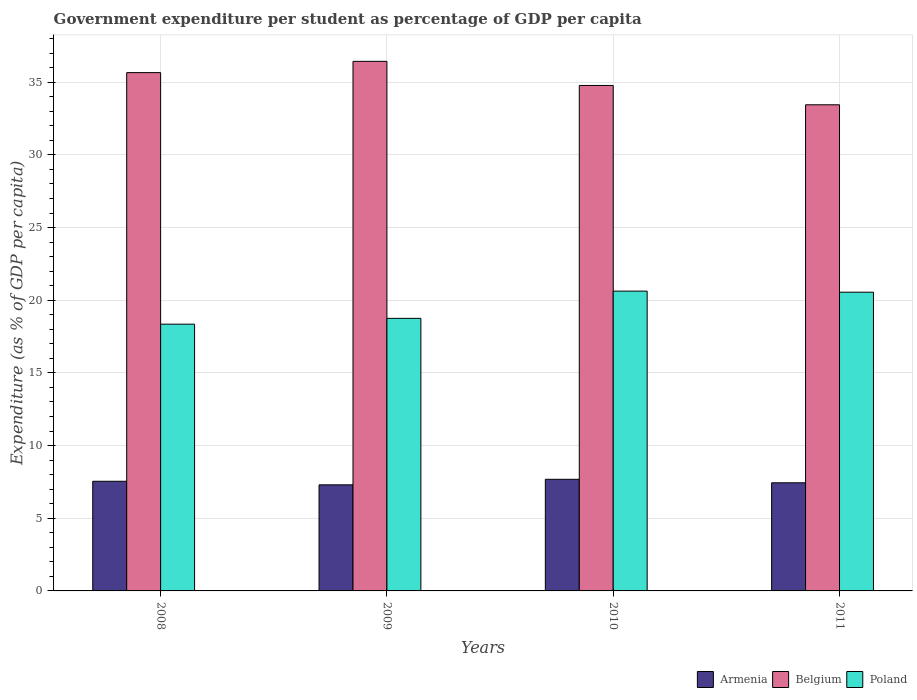Are the number of bars on each tick of the X-axis equal?
Offer a terse response. Yes. How many bars are there on the 3rd tick from the left?
Your response must be concise. 3. How many bars are there on the 1st tick from the right?
Give a very brief answer. 3. What is the label of the 1st group of bars from the left?
Your answer should be compact. 2008. In how many cases, is the number of bars for a given year not equal to the number of legend labels?
Offer a very short reply. 0. What is the percentage of expenditure per student in Armenia in 2010?
Provide a succinct answer. 7.68. Across all years, what is the maximum percentage of expenditure per student in Belgium?
Provide a succinct answer. 36.43. Across all years, what is the minimum percentage of expenditure per student in Poland?
Your response must be concise. 18.35. In which year was the percentage of expenditure per student in Belgium maximum?
Keep it short and to the point. 2009. In which year was the percentage of expenditure per student in Poland minimum?
Provide a short and direct response. 2008. What is the total percentage of expenditure per student in Belgium in the graph?
Give a very brief answer. 140.31. What is the difference between the percentage of expenditure per student in Armenia in 2009 and that in 2011?
Ensure brevity in your answer.  -0.14. What is the difference between the percentage of expenditure per student in Poland in 2008 and the percentage of expenditure per student in Armenia in 2010?
Offer a very short reply. 10.67. What is the average percentage of expenditure per student in Belgium per year?
Your answer should be very brief. 35.08. In the year 2010, what is the difference between the percentage of expenditure per student in Armenia and percentage of expenditure per student in Poland?
Your answer should be compact. -12.95. What is the ratio of the percentage of expenditure per student in Poland in 2009 to that in 2010?
Offer a terse response. 0.91. What is the difference between the highest and the second highest percentage of expenditure per student in Belgium?
Make the answer very short. 0.77. What is the difference between the highest and the lowest percentage of expenditure per student in Poland?
Offer a terse response. 2.27. In how many years, is the percentage of expenditure per student in Armenia greater than the average percentage of expenditure per student in Armenia taken over all years?
Offer a very short reply. 2. Is the sum of the percentage of expenditure per student in Belgium in 2008 and 2009 greater than the maximum percentage of expenditure per student in Armenia across all years?
Provide a succinct answer. Yes. What does the 3rd bar from the right in 2010 represents?
Offer a very short reply. Armenia. Is it the case that in every year, the sum of the percentage of expenditure per student in Belgium and percentage of expenditure per student in Poland is greater than the percentage of expenditure per student in Armenia?
Make the answer very short. Yes. How many bars are there?
Ensure brevity in your answer.  12. What is the difference between two consecutive major ticks on the Y-axis?
Provide a succinct answer. 5. Does the graph contain any zero values?
Your answer should be compact. No. What is the title of the graph?
Ensure brevity in your answer.  Government expenditure per student as percentage of GDP per capita. Does "Nepal" appear as one of the legend labels in the graph?
Provide a short and direct response. No. What is the label or title of the X-axis?
Ensure brevity in your answer.  Years. What is the label or title of the Y-axis?
Your response must be concise. Expenditure (as % of GDP per capita). What is the Expenditure (as % of GDP per capita) in Armenia in 2008?
Ensure brevity in your answer.  7.54. What is the Expenditure (as % of GDP per capita) of Belgium in 2008?
Make the answer very short. 35.66. What is the Expenditure (as % of GDP per capita) of Poland in 2008?
Ensure brevity in your answer.  18.35. What is the Expenditure (as % of GDP per capita) in Armenia in 2009?
Make the answer very short. 7.3. What is the Expenditure (as % of GDP per capita) in Belgium in 2009?
Make the answer very short. 36.43. What is the Expenditure (as % of GDP per capita) in Poland in 2009?
Keep it short and to the point. 18.75. What is the Expenditure (as % of GDP per capita) in Armenia in 2010?
Offer a terse response. 7.68. What is the Expenditure (as % of GDP per capita) of Belgium in 2010?
Offer a very short reply. 34.77. What is the Expenditure (as % of GDP per capita) of Poland in 2010?
Keep it short and to the point. 20.63. What is the Expenditure (as % of GDP per capita) in Armenia in 2011?
Provide a short and direct response. 7.44. What is the Expenditure (as % of GDP per capita) in Belgium in 2011?
Offer a terse response. 33.44. What is the Expenditure (as % of GDP per capita) of Poland in 2011?
Offer a terse response. 20.55. Across all years, what is the maximum Expenditure (as % of GDP per capita) in Armenia?
Your answer should be compact. 7.68. Across all years, what is the maximum Expenditure (as % of GDP per capita) of Belgium?
Your answer should be very brief. 36.43. Across all years, what is the maximum Expenditure (as % of GDP per capita) in Poland?
Your response must be concise. 20.63. Across all years, what is the minimum Expenditure (as % of GDP per capita) of Armenia?
Ensure brevity in your answer.  7.3. Across all years, what is the minimum Expenditure (as % of GDP per capita) of Belgium?
Provide a short and direct response. 33.44. Across all years, what is the minimum Expenditure (as % of GDP per capita) of Poland?
Offer a very short reply. 18.35. What is the total Expenditure (as % of GDP per capita) of Armenia in the graph?
Your answer should be very brief. 29.96. What is the total Expenditure (as % of GDP per capita) in Belgium in the graph?
Offer a terse response. 140.31. What is the total Expenditure (as % of GDP per capita) in Poland in the graph?
Offer a terse response. 78.28. What is the difference between the Expenditure (as % of GDP per capita) in Armenia in 2008 and that in 2009?
Keep it short and to the point. 0.25. What is the difference between the Expenditure (as % of GDP per capita) of Belgium in 2008 and that in 2009?
Make the answer very short. -0.77. What is the difference between the Expenditure (as % of GDP per capita) in Poland in 2008 and that in 2009?
Provide a short and direct response. -0.4. What is the difference between the Expenditure (as % of GDP per capita) in Armenia in 2008 and that in 2010?
Ensure brevity in your answer.  -0.14. What is the difference between the Expenditure (as % of GDP per capita) in Belgium in 2008 and that in 2010?
Ensure brevity in your answer.  0.88. What is the difference between the Expenditure (as % of GDP per capita) of Poland in 2008 and that in 2010?
Your response must be concise. -2.27. What is the difference between the Expenditure (as % of GDP per capita) in Armenia in 2008 and that in 2011?
Your answer should be very brief. 0.11. What is the difference between the Expenditure (as % of GDP per capita) of Belgium in 2008 and that in 2011?
Offer a very short reply. 2.21. What is the difference between the Expenditure (as % of GDP per capita) in Poland in 2008 and that in 2011?
Make the answer very short. -2.2. What is the difference between the Expenditure (as % of GDP per capita) of Armenia in 2009 and that in 2010?
Provide a short and direct response. -0.38. What is the difference between the Expenditure (as % of GDP per capita) in Belgium in 2009 and that in 2010?
Your answer should be compact. 1.66. What is the difference between the Expenditure (as % of GDP per capita) in Poland in 2009 and that in 2010?
Give a very brief answer. -1.87. What is the difference between the Expenditure (as % of GDP per capita) in Armenia in 2009 and that in 2011?
Offer a terse response. -0.14. What is the difference between the Expenditure (as % of GDP per capita) of Belgium in 2009 and that in 2011?
Make the answer very short. 2.99. What is the difference between the Expenditure (as % of GDP per capita) in Poland in 2009 and that in 2011?
Ensure brevity in your answer.  -1.8. What is the difference between the Expenditure (as % of GDP per capita) in Armenia in 2010 and that in 2011?
Give a very brief answer. 0.24. What is the difference between the Expenditure (as % of GDP per capita) in Belgium in 2010 and that in 2011?
Your answer should be very brief. 1.33. What is the difference between the Expenditure (as % of GDP per capita) of Poland in 2010 and that in 2011?
Provide a short and direct response. 0.08. What is the difference between the Expenditure (as % of GDP per capita) in Armenia in 2008 and the Expenditure (as % of GDP per capita) in Belgium in 2009?
Give a very brief answer. -28.89. What is the difference between the Expenditure (as % of GDP per capita) of Armenia in 2008 and the Expenditure (as % of GDP per capita) of Poland in 2009?
Offer a terse response. -11.21. What is the difference between the Expenditure (as % of GDP per capita) of Belgium in 2008 and the Expenditure (as % of GDP per capita) of Poland in 2009?
Offer a very short reply. 16.91. What is the difference between the Expenditure (as % of GDP per capita) in Armenia in 2008 and the Expenditure (as % of GDP per capita) in Belgium in 2010?
Ensure brevity in your answer.  -27.23. What is the difference between the Expenditure (as % of GDP per capita) of Armenia in 2008 and the Expenditure (as % of GDP per capita) of Poland in 2010?
Give a very brief answer. -13.08. What is the difference between the Expenditure (as % of GDP per capita) in Belgium in 2008 and the Expenditure (as % of GDP per capita) in Poland in 2010?
Your answer should be compact. 15.03. What is the difference between the Expenditure (as % of GDP per capita) in Armenia in 2008 and the Expenditure (as % of GDP per capita) in Belgium in 2011?
Provide a short and direct response. -25.9. What is the difference between the Expenditure (as % of GDP per capita) in Armenia in 2008 and the Expenditure (as % of GDP per capita) in Poland in 2011?
Make the answer very short. -13.01. What is the difference between the Expenditure (as % of GDP per capita) in Belgium in 2008 and the Expenditure (as % of GDP per capita) in Poland in 2011?
Your response must be concise. 15.11. What is the difference between the Expenditure (as % of GDP per capita) in Armenia in 2009 and the Expenditure (as % of GDP per capita) in Belgium in 2010?
Your response must be concise. -27.48. What is the difference between the Expenditure (as % of GDP per capita) in Armenia in 2009 and the Expenditure (as % of GDP per capita) in Poland in 2010?
Give a very brief answer. -13.33. What is the difference between the Expenditure (as % of GDP per capita) in Belgium in 2009 and the Expenditure (as % of GDP per capita) in Poland in 2010?
Ensure brevity in your answer.  15.81. What is the difference between the Expenditure (as % of GDP per capita) of Armenia in 2009 and the Expenditure (as % of GDP per capita) of Belgium in 2011?
Offer a very short reply. -26.15. What is the difference between the Expenditure (as % of GDP per capita) in Armenia in 2009 and the Expenditure (as % of GDP per capita) in Poland in 2011?
Offer a terse response. -13.25. What is the difference between the Expenditure (as % of GDP per capita) of Belgium in 2009 and the Expenditure (as % of GDP per capita) of Poland in 2011?
Make the answer very short. 15.88. What is the difference between the Expenditure (as % of GDP per capita) in Armenia in 2010 and the Expenditure (as % of GDP per capita) in Belgium in 2011?
Ensure brevity in your answer.  -25.77. What is the difference between the Expenditure (as % of GDP per capita) in Armenia in 2010 and the Expenditure (as % of GDP per capita) in Poland in 2011?
Provide a short and direct response. -12.87. What is the difference between the Expenditure (as % of GDP per capita) in Belgium in 2010 and the Expenditure (as % of GDP per capita) in Poland in 2011?
Your answer should be compact. 14.22. What is the average Expenditure (as % of GDP per capita) of Armenia per year?
Your answer should be very brief. 7.49. What is the average Expenditure (as % of GDP per capita) of Belgium per year?
Provide a short and direct response. 35.08. What is the average Expenditure (as % of GDP per capita) of Poland per year?
Give a very brief answer. 19.57. In the year 2008, what is the difference between the Expenditure (as % of GDP per capita) of Armenia and Expenditure (as % of GDP per capita) of Belgium?
Your response must be concise. -28.11. In the year 2008, what is the difference between the Expenditure (as % of GDP per capita) in Armenia and Expenditure (as % of GDP per capita) in Poland?
Provide a short and direct response. -10.81. In the year 2008, what is the difference between the Expenditure (as % of GDP per capita) of Belgium and Expenditure (as % of GDP per capita) of Poland?
Offer a very short reply. 17.31. In the year 2009, what is the difference between the Expenditure (as % of GDP per capita) of Armenia and Expenditure (as % of GDP per capita) of Belgium?
Your answer should be very brief. -29.13. In the year 2009, what is the difference between the Expenditure (as % of GDP per capita) of Armenia and Expenditure (as % of GDP per capita) of Poland?
Offer a terse response. -11.45. In the year 2009, what is the difference between the Expenditure (as % of GDP per capita) in Belgium and Expenditure (as % of GDP per capita) in Poland?
Offer a very short reply. 17.68. In the year 2010, what is the difference between the Expenditure (as % of GDP per capita) in Armenia and Expenditure (as % of GDP per capita) in Belgium?
Your answer should be compact. -27.1. In the year 2010, what is the difference between the Expenditure (as % of GDP per capita) of Armenia and Expenditure (as % of GDP per capita) of Poland?
Keep it short and to the point. -12.95. In the year 2010, what is the difference between the Expenditure (as % of GDP per capita) in Belgium and Expenditure (as % of GDP per capita) in Poland?
Provide a succinct answer. 14.15. In the year 2011, what is the difference between the Expenditure (as % of GDP per capita) of Armenia and Expenditure (as % of GDP per capita) of Belgium?
Offer a terse response. -26.01. In the year 2011, what is the difference between the Expenditure (as % of GDP per capita) in Armenia and Expenditure (as % of GDP per capita) in Poland?
Offer a terse response. -13.11. In the year 2011, what is the difference between the Expenditure (as % of GDP per capita) in Belgium and Expenditure (as % of GDP per capita) in Poland?
Ensure brevity in your answer.  12.89. What is the ratio of the Expenditure (as % of GDP per capita) in Armenia in 2008 to that in 2009?
Offer a very short reply. 1.03. What is the ratio of the Expenditure (as % of GDP per capita) in Belgium in 2008 to that in 2009?
Ensure brevity in your answer.  0.98. What is the ratio of the Expenditure (as % of GDP per capita) of Poland in 2008 to that in 2009?
Ensure brevity in your answer.  0.98. What is the ratio of the Expenditure (as % of GDP per capita) of Armenia in 2008 to that in 2010?
Ensure brevity in your answer.  0.98. What is the ratio of the Expenditure (as % of GDP per capita) in Belgium in 2008 to that in 2010?
Keep it short and to the point. 1.03. What is the ratio of the Expenditure (as % of GDP per capita) in Poland in 2008 to that in 2010?
Ensure brevity in your answer.  0.89. What is the ratio of the Expenditure (as % of GDP per capita) of Armenia in 2008 to that in 2011?
Offer a very short reply. 1.01. What is the ratio of the Expenditure (as % of GDP per capita) of Belgium in 2008 to that in 2011?
Give a very brief answer. 1.07. What is the ratio of the Expenditure (as % of GDP per capita) in Poland in 2008 to that in 2011?
Your answer should be compact. 0.89. What is the ratio of the Expenditure (as % of GDP per capita) of Armenia in 2009 to that in 2010?
Give a very brief answer. 0.95. What is the ratio of the Expenditure (as % of GDP per capita) of Belgium in 2009 to that in 2010?
Make the answer very short. 1.05. What is the ratio of the Expenditure (as % of GDP per capita) in Poland in 2009 to that in 2010?
Ensure brevity in your answer.  0.91. What is the ratio of the Expenditure (as % of GDP per capita) in Armenia in 2009 to that in 2011?
Offer a very short reply. 0.98. What is the ratio of the Expenditure (as % of GDP per capita) of Belgium in 2009 to that in 2011?
Give a very brief answer. 1.09. What is the ratio of the Expenditure (as % of GDP per capita) in Poland in 2009 to that in 2011?
Provide a short and direct response. 0.91. What is the ratio of the Expenditure (as % of GDP per capita) in Armenia in 2010 to that in 2011?
Offer a very short reply. 1.03. What is the ratio of the Expenditure (as % of GDP per capita) of Belgium in 2010 to that in 2011?
Offer a very short reply. 1.04. What is the difference between the highest and the second highest Expenditure (as % of GDP per capita) in Armenia?
Make the answer very short. 0.14. What is the difference between the highest and the second highest Expenditure (as % of GDP per capita) of Belgium?
Offer a very short reply. 0.77. What is the difference between the highest and the second highest Expenditure (as % of GDP per capita) in Poland?
Offer a very short reply. 0.08. What is the difference between the highest and the lowest Expenditure (as % of GDP per capita) in Armenia?
Give a very brief answer. 0.38. What is the difference between the highest and the lowest Expenditure (as % of GDP per capita) in Belgium?
Your response must be concise. 2.99. What is the difference between the highest and the lowest Expenditure (as % of GDP per capita) of Poland?
Keep it short and to the point. 2.27. 